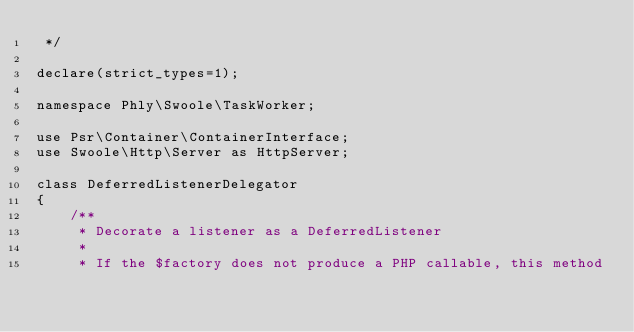Convert code to text. <code><loc_0><loc_0><loc_500><loc_500><_PHP_> */

declare(strict_types=1);

namespace Phly\Swoole\TaskWorker;

use Psr\Container\ContainerInterface;
use Swoole\Http\Server as HttpServer;

class DeferredListenerDelegator
{
    /**
     * Decorate a listener as a DeferredListener
     *
     * If the $factory does not produce a PHP callable, this method</code> 